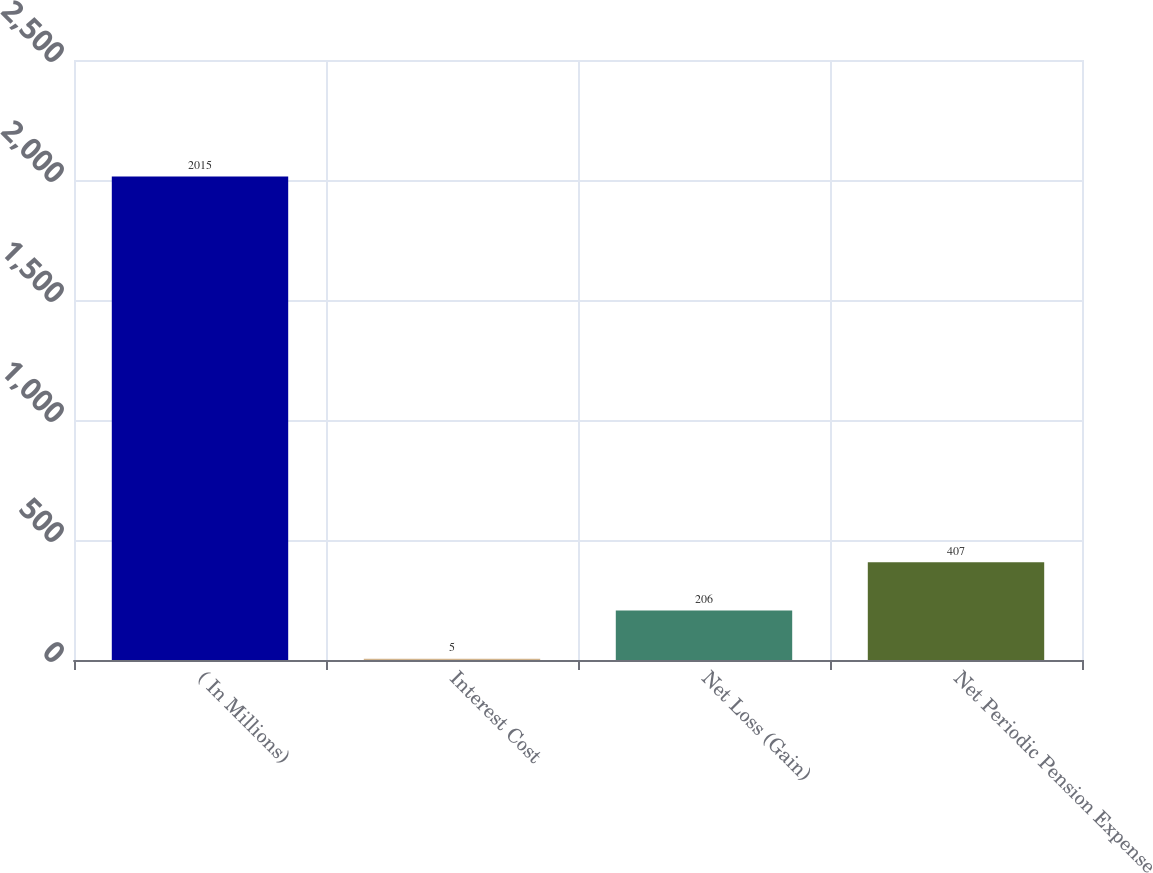Convert chart. <chart><loc_0><loc_0><loc_500><loc_500><bar_chart><fcel>( In Millions)<fcel>Interest Cost<fcel>Net Loss (Gain)<fcel>Net Periodic Pension Expense<nl><fcel>2015<fcel>5<fcel>206<fcel>407<nl></chart> 